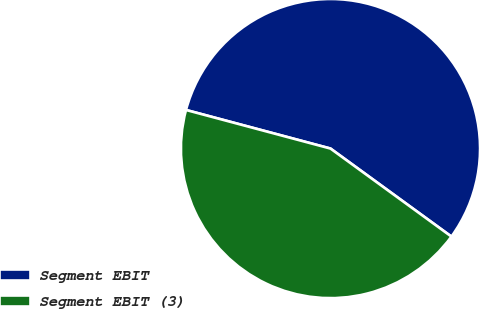<chart> <loc_0><loc_0><loc_500><loc_500><pie_chart><fcel>Segment EBIT<fcel>Segment EBIT (3)<nl><fcel>55.86%<fcel>44.14%<nl></chart> 